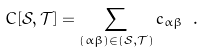<formula> <loc_0><loc_0><loc_500><loc_500>C [ \mathcal { S } , \mathcal { T } ] = \sum _ { ( \alpha \beta ) \in ( \mathcal { S } , \mathcal { T } ) } c _ { \alpha \beta } \ .</formula> 